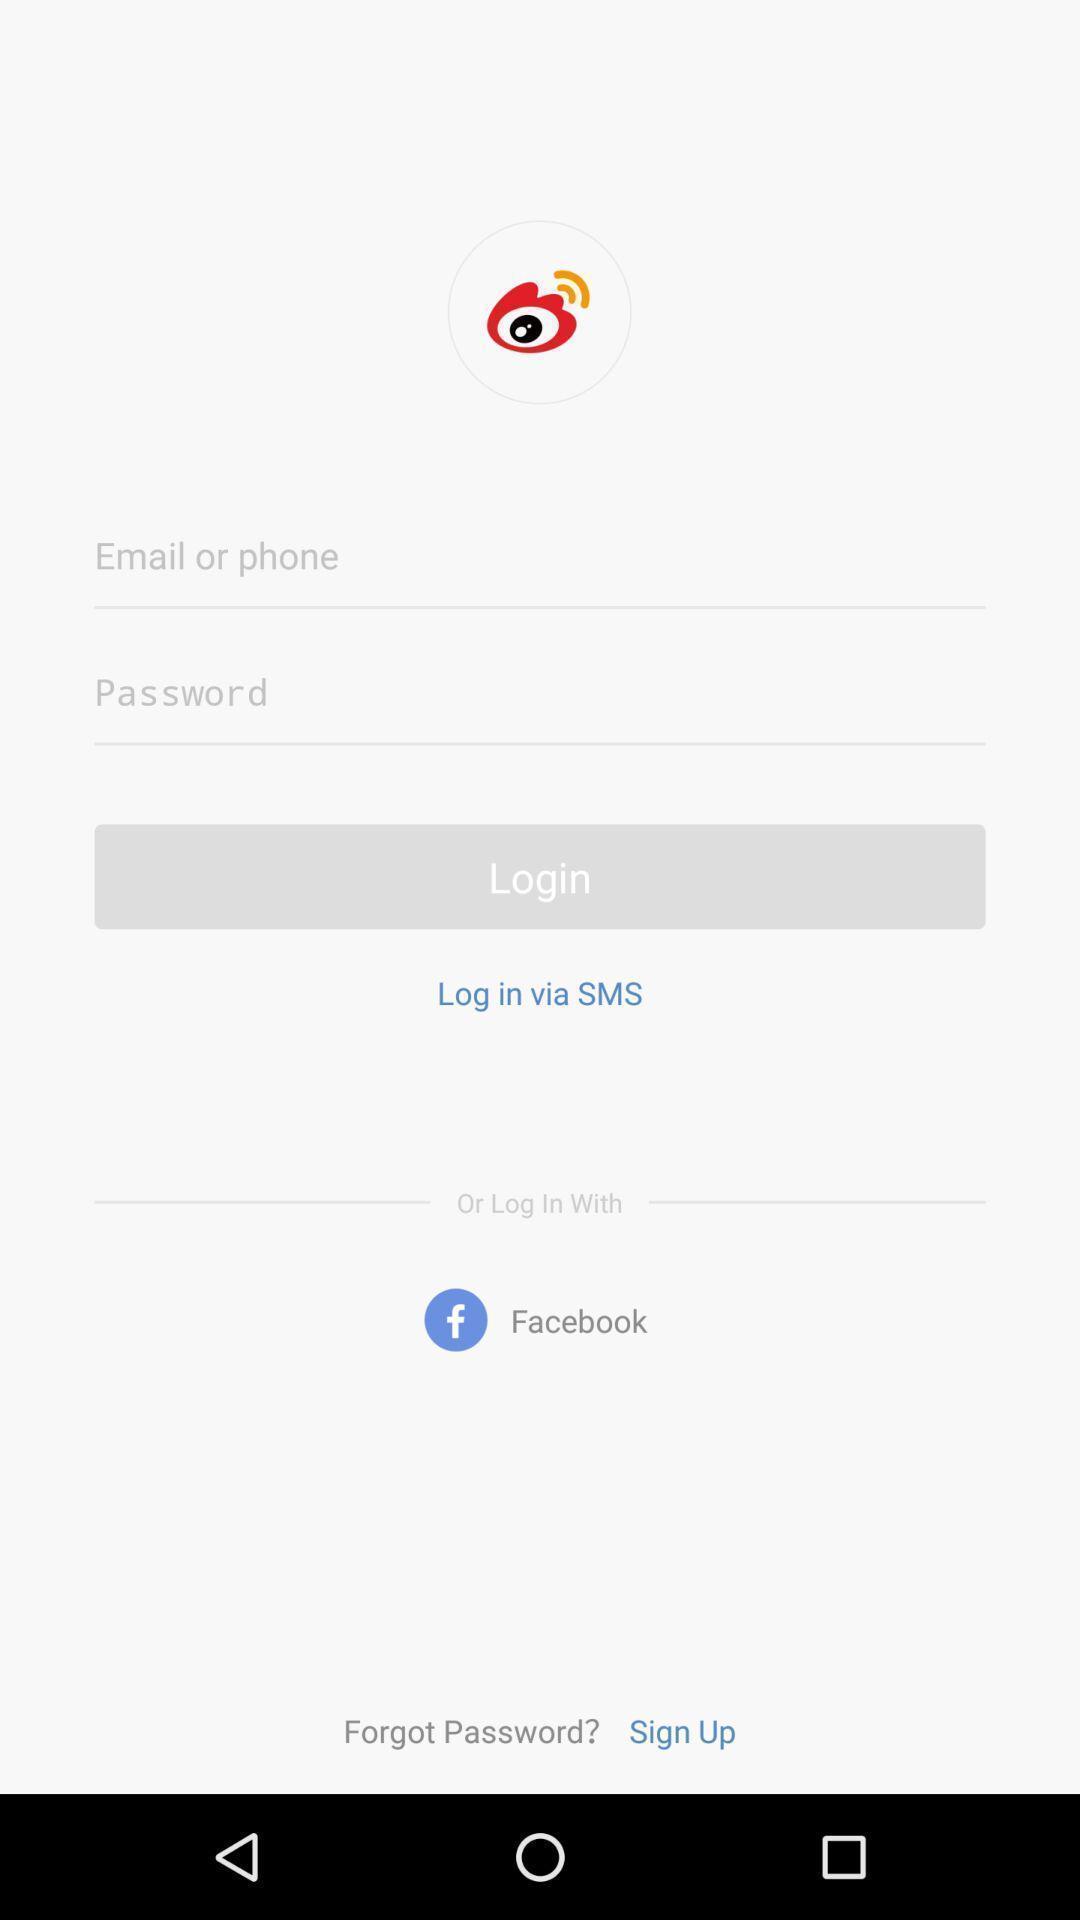Explain what's happening in this screen capture. Login page. 